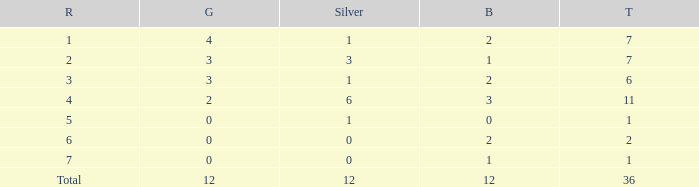What is the largest total for a team with 1 bronze, 0 gold medals and ranking of 7? None. 